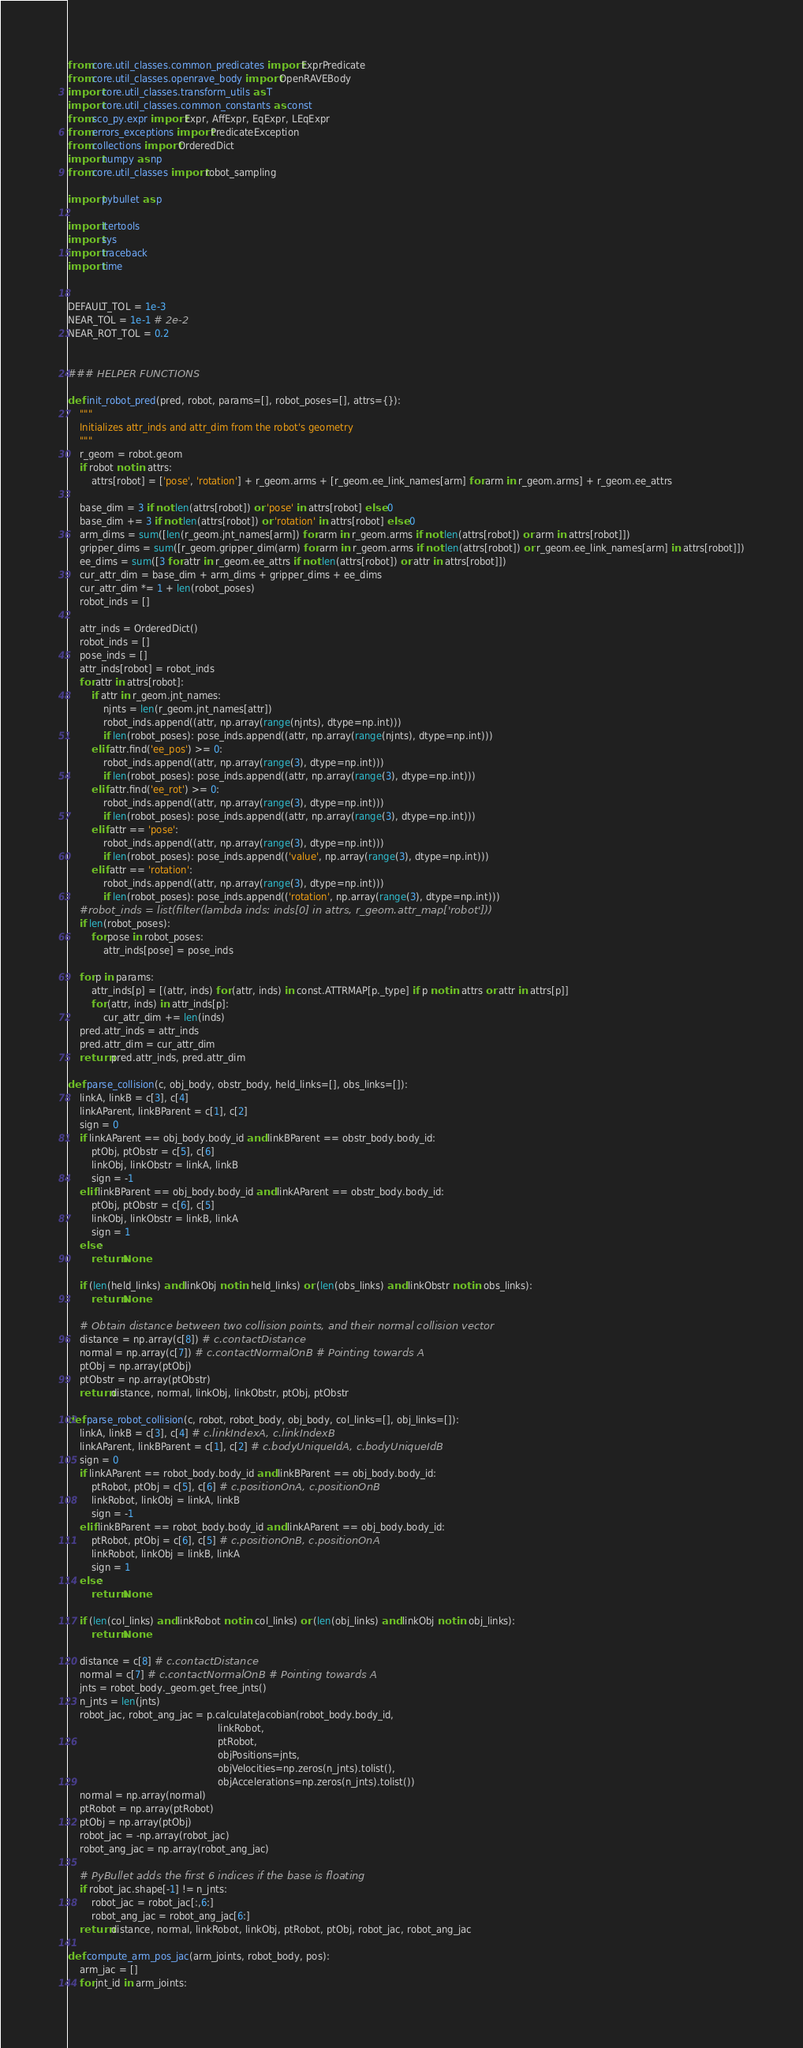<code> <loc_0><loc_0><loc_500><loc_500><_Python_>from core.util_classes.common_predicates import ExprPredicate
from core.util_classes.openrave_body import OpenRAVEBody
import core.util_classes.transform_utils as T
import core.util_classes.common_constants as const
from sco_py.expr import Expr, AffExpr, EqExpr, LEqExpr
from errors_exceptions import PredicateException
from collections import OrderedDict
import numpy as np
from core.util_classes import robot_sampling

import pybullet as p

import itertools
import sys
import traceback
import time


DEFAULT_TOL = 1e-3
NEAR_TOL = 1e-1 # 2e-2
NEAR_ROT_TOL = 0.2


### HELPER FUNCTIONS

def init_robot_pred(pred, robot, params=[], robot_poses=[], attrs={}):
    """
    Initializes attr_inds and attr_dim from the robot's geometry
    """
    r_geom = robot.geom
    if robot not in attrs:
        attrs[robot] = ['pose', 'rotation'] + r_geom.arms + [r_geom.ee_link_names[arm] for arm in r_geom.arms] + r_geom.ee_attrs

    base_dim = 3 if not len(attrs[robot]) or 'pose' in attrs[robot] else 0
    base_dim += 3 if not len(attrs[robot]) or 'rotation' in attrs[robot] else 0
    arm_dims = sum([len(r_geom.jnt_names[arm]) for arm in r_geom.arms if not len(attrs[robot]) or arm in attrs[robot]])
    gripper_dims = sum([r_geom.gripper_dim(arm) for arm in r_geom.arms if not len(attrs[robot]) or r_geom.ee_link_names[arm] in attrs[robot]])
    ee_dims = sum([3 for attr in r_geom.ee_attrs if not len(attrs[robot]) or attr in attrs[robot]])
    cur_attr_dim = base_dim + arm_dims + gripper_dims + ee_dims
    cur_attr_dim *= 1 + len(robot_poses)
    robot_inds = []

    attr_inds = OrderedDict()
    robot_inds = []
    pose_inds = []
    attr_inds[robot] = robot_inds
    for attr in attrs[robot]:
        if attr in r_geom.jnt_names:
            njnts = len(r_geom.jnt_names[attr])
            robot_inds.append((attr, np.array(range(njnts), dtype=np.int)))
            if len(robot_poses): pose_inds.append((attr, np.array(range(njnts), dtype=np.int)))
        elif attr.find('ee_pos') >= 0:
            robot_inds.append((attr, np.array(range(3), dtype=np.int)))
            if len(robot_poses): pose_inds.append((attr, np.array(range(3), dtype=np.int)))
        elif attr.find('ee_rot') >= 0:
            robot_inds.append((attr, np.array(range(3), dtype=np.int)))
            if len(robot_poses): pose_inds.append((attr, np.array(range(3), dtype=np.int)))
        elif attr == 'pose':
            robot_inds.append((attr, np.array(range(3), dtype=np.int)))
            if len(robot_poses): pose_inds.append(('value', np.array(range(3), dtype=np.int)))
        elif attr == 'rotation':
            robot_inds.append((attr, np.array(range(3), dtype=np.int)))
            if len(robot_poses): pose_inds.append(('rotation', np.array(range(3), dtype=np.int)))
    #robot_inds = list(filter(lambda inds: inds[0] in attrs, r_geom.attr_map['robot']))
    if len(robot_poses):
        for pose in robot_poses:
            attr_inds[pose] = pose_inds

    for p in params:
        attr_inds[p] = [(attr, inds) for (attr, inds) in const.ATTRMAP[p._type] if p not in attrs or attr in attrs[p]]
        for (attr, inds) in attr_inds[p]:
            cur_attr_dim += len(inds)
    pred.attr_inds = attr_inds
    pred.attr_dim = cur_attr_dim
    return pred.attr_inds, pred.attr_dim

def parse_collision(c, obj_body, obstr_body, held_links=[], obs_links=[]):
    linkA, linkB = c[3], c[4]
    linkAParent, linkBParent = c[1], c[2]
    sign = 0
    if linkAParent == obj_body.body_id and linkBParent == obstr_body.body_id:
        ptObj, ptObstr = c[5], c[6]
        linkObj, linkObstr = linkA, linkB
        sign = -1
    elif linkBParent == obj_body.body_id and linkAParent == obstr_body.body_id:
        ptObj, ptObstr = c[6], c[5]
        linkObj, linkObstr = linkB, linkA
        sign = 1
    else:
        return None

    if (len(held_links) and linkObj not in held_links) or (len(obs_links) and linkObstr not in obs_links):
        return None

    # Obtain distance between two collision points, and their normal collision vector
    distance = np.array(c[8]) # c.contactDistance
    normal = np.array(c[7]) # c.contactNormalOnB # Pointing towards A
    ptObj = np.array(ptObj)
    ptObstr = np.array(ptObstr)
    return distance, normal, linkObj, linkObstr, ptObj, ptObstr

def parse_robot_collision(c, robot, robot_body, obj_body, col_links=[], obj_links=[]):
    linkA, linkB = c[3], c[4] # c.linkIndexA, c.linkIndexB
    linkAParent, linkBParent = c[1], c[2] # c.bodyUniqueIdA, c.bodyUniqueIdB
    sign = 0
    if linkAParent == robot_body.body_id and linkBParent == obj_body.body_id:
        ptRobot, ptObj = c[5], c[6] # c.positionOnA, c.positionOnB
        linkRobot, linkObj = linkA, linkB
        sign = -1
    elif linkBParent == robot_body.body_id and linkAParent == obj_body.body_id:
        ptRobot, ptObj = c[6], c[5] # c.positionOnB, c.positionOnA
        linkRobot, linkObj = linkB, linkA
        sign = 1
    else:
        return None

    if (len(col_links) and linkRobot not in col_links) or (len(obj_links) and linkObj not in obj_links):
        return None

    distance = c[8] # c.contactDistance
    normal = c[7] # c.contactNormalOnB # Pointing towards A
    jnts = robot_body._geom.get_free_jnts()
    n_jnts = len(jnts)
    robot_jac, robot_ang_jac = p.calculateJacobian(robot_body.body_id,
                                                   linkRobot,
                                                   ptRobot,
                                                   objPositions=jnts,
                                                   objVelocities=np.zeros(n_jnts).tolist(),
                                                   objAccelerations=np.zeros(n_jnts).tolist())
    normal = np.array(normal)
    ptRobot = np.array(ptRobot)
    ptObj = np.array(ptObj)
    robot_jac = -np.array(robot_jac)
    robot_ang_jac = np.array(robot_ang_jac)

    # PyBullet adds the first 6 indices if the base is floating
    if robot_jac.shape[-1] != n_jnts:
        robot_jac = robot_jac[:,6:]
        robot_ang_jac = robot_ang_jac[6:]
    return distance, normal, linkRobot, linkObj, ptRobot, ptObj, robot_jac, robot_ang_jac

def compute_arm_pos_jac(arm_joints, robot_body, pos):
    arm_jac = []
    for jnt_id in arm_joints:</code> 